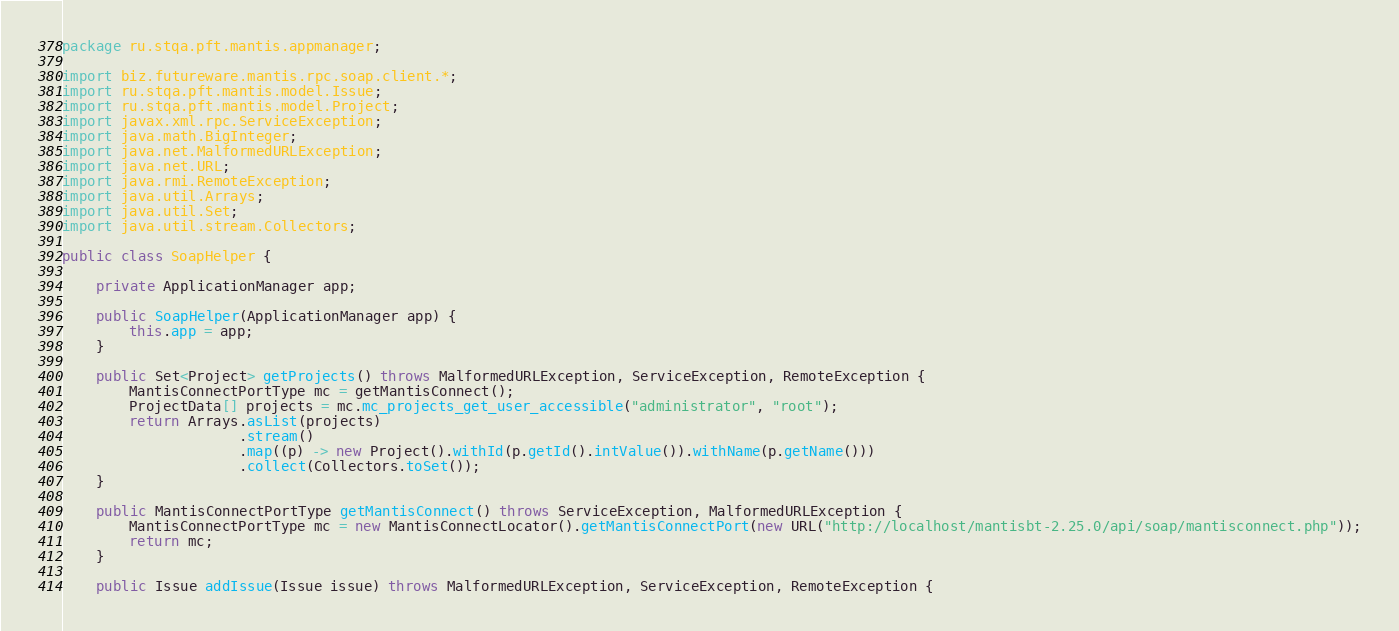Convert code to text. <code><loc_0><loc_0><loc_500><loc_500><_Java_>package ru.stqa.pft.mantis.appmanager;

import biz.futureware.mantis.rpc.soap.client.*;
import ru.stqa.pft.mantis.model.Issue;
import ru.stqa.pft.mantis.model.Project;
import javax.xml.rpc.ServiceException;
import java.math.BigInteger;
import java.net.MalformedURLException;
import java.net.URL;
import java.rmi.RemoteException;
import java.util.Arrays;
import java.util.Set;
import java.util.stream.Collectors;

public class SoapHelper {

    private ApplicationManager app;

    public SoapHelper(ApplicationManager app) {
        this.app = app;
    }

    public Set<Project> getProjects() throws MalformedURLException, ServiceException, RemoteException {
        MantisConnectPortType mc = getMantisConnect();
        ProjectData[] projects = mc.mc_projects_get_user_accessible("administrator", "root");
        return Arrays.asList(projects)
                     .stream()
                     .map((p) -> new Project().withId(p.getId().intValue()).withName(p.getName()))
                     .collect(Collectors.toSet());
    }

    public MantisConnectPortType getMantisConnect() throws ServiceException, MalformedURLException {
        MantisConnectPortType mc = new MantisConnectLocator().getMantisConnectPort(new URL("http://localhost/mantisbt-2.25.0/api/soap/mantisconnect.php"));
        return mc;
    }

    public Issue addIssue(Issue issue) throws MalformedURLException, ServiceException, RemoteException {</code> 